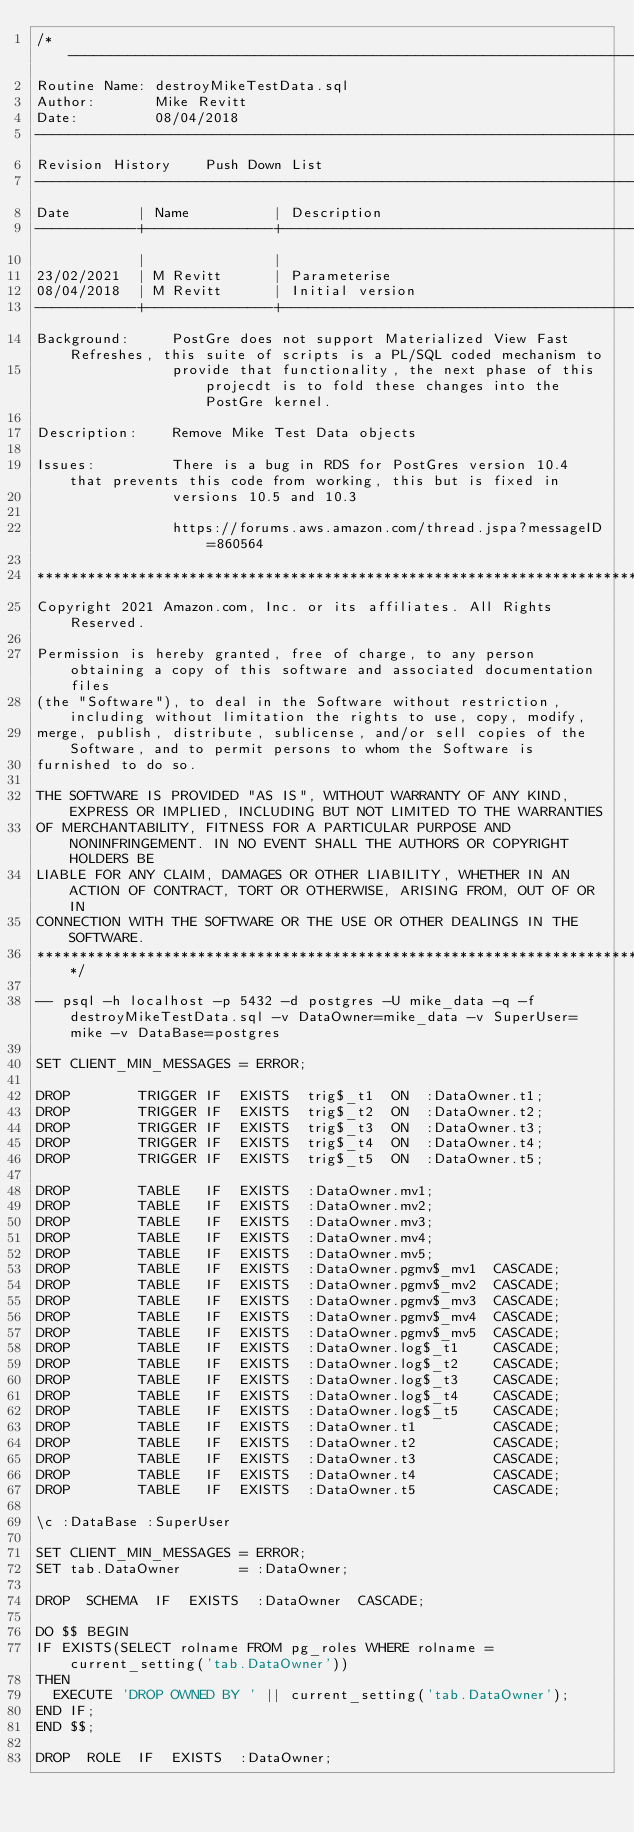Convert code to text. <code><loc_0><loc_0><loc_500><loc_500><_SQL_>/* ---------------------------------------------------------------------------------------------------------------------------------
Routine Name: destroyMikeTestData.sql
Author:       Mike Revitt
Date:         08/04/2018
------------------------------------------------------------------------------------------------------------------------------------
Revision History    Push Down List
------------------------------------------------------------------------------------------------------------------------------------
Date        | Name          | Description
------------+---------------+-------------------------------------------------------------------------------------------------------
            |               |
23/02/2021  | M Revitt      | Parameterise
08/04/2018  | M Revitt      | Initial version
------------+---------------+-------------------------------------------------------------------------------------------------------
Background:     PostGre does not support Materialized View Fast Refreshes, this suite of scripts is a PL/SQL coded mechanism to
                provide that functionality, the next phase of this projecdt is to fold these changes into the PostGre kernel.

Description:    Remove Mike Test Data objects

Issues:         There is a bug in RDS for PostGres version 10.4 that prevents this code from working, this but is fixed in
                versions 10.5 and 10.3

                https://forums.aws.amazon.com/thread.jspa?messageID=860564

************************************************************************************************************************************
Copyright 2021 Amazon.com, Inc. or its affiliates. All Rights Reserved.

Permission is hereby granted, free of charge, to any person obtaining a copy of this software and associated documentation files
(the "Software"), to deal in the Software without restriction, including without limitation the rights to use, copy, modify,
merge, publish, distribute, sublicense, and/or sell copies of the Software, and to permit persons to whom the Software is
furnished to do so.

THE SOFTWARE IS PROVIDED "AS IS", WITHOUT WARRANTY OF ANY KIND, EXPRESS OR IMPLIED, INCLUDING BUT NOT LIMITED TO THE WARRANTIES
OF MERCHANTABILITY, FITNESS FOR A PARTICULAR PURPOSE AND NONINFRINGEMENT. IN NO EVENT SHALL THE AUTHORS OR COPYRIGHT HOLDERS BE
LIABLE FOR ANY CLAIM, DAMAGES OR OTHER LIABILITY, WHETHER IN AN ACTION OF CONTRACT, TORT OR OTHERWISE, ARISING FROM, OUT OF OR IN
CONNECTION WITH THE SOFTWARE OR THE USE OR OTHER DEALINGS IN THE SOFTWARE.
***********************************************************************************************************************************/

-- psql -h localhost -p 5432 -d postgres -U mike_data -q -f destroyMikeTestData.sql -v DataOwner=mike_data -v SuperUser=mike -v DataBase=postgres

SET CLIENT_MIN_MESSAGES = ERROR;

DROP        TRIGGER IF  EXISTS  trig$_t1  ON  :DataOwner.t1;
DROP        TRIGGER IF  EXISTS  trig$_t2  ON  :DataOwner.t2;
DROP        TRIGGER IF  EXISTS  trig$_t3  ON  :DataOwner.t3;
DROP        TRIGGER IF  EXISTS  trig$_t4  ON  :DataOwner.t4;
DROP        TRIGGER IF  EXISTS  trig$_t5  ON  :DataOwner.t5;

DROP        TABLE   IF  EXISTS  :DataOwner.mv1;
DROP        TABLE   IF  EXISTS  :DataOwner.mv2;
DROP        TABLE   IF  EXISTS  :DataOwner.mv3;
DROP        TABLE   IF  EXISTS  :DataOwner.mv4;
DROP        TABLE   IF  EXISTS  :DataOwner.mv5;
DROP        TABLE   IF  EXISTS  :DataOwner.pgmv$_mv1  CASCADE;
DROP        TABLE   IF  EXISTS  :DataOwner.pgmv$_mv2  CASCADE;
DROP        TABLE   IF  EXISTS  :DataOwner.pgmv$_mv3  CASCADE;
DROP        TABLE   IF  EXISTS  :DataOwner.pgmv$_mv4  CASCADE;
DROP        TABLE   IF  EXISTS  :DataOwner.pgmv$_mv5  CASCADE;
DROP        TABLE   IF  EXISTS  :DataOwner.log$_t1    CASCADE;
DROP        TABLE   IF  EXISTS  :DataOwner.log$_t2    CASCADE;
DROP        TABLE   IF  EXISTS  :DataOwner.log$_t3    CASCADE;
DROP        TABLE   IF  EXISTS  :DataOwner.log$_t4    CASCADE;
DROP        TABLE   IF  EXISTS  :DataOwner.log$_t5    CASCADE;
DROP        TABLE   IF  EXISTS  :DataOwner.t1         CASCADE;
DROP        TABLE   IF  EXISTS  :DataOwner.t2         CASCADE;
DROP        TABLE   IF  EXISTS  :DataOwner.t3         CASCADE;
DROP        TABLE   IF  EXISTS  :DataOwner.t4         CASCADE;
DROP        TABLE   IF  EXISTS  :DataOwner.t5         CASCADE;

\c :DataBase :SuperUser

SET CLIENT_MIN_MESSAGES = ERROR;
SET tab.DataOwner       = :DataOwner;

DROP  SCHEMA  IF  EXISTS  :DataOwner  CASCADE;

DO $$ BEGIN
IF EXISTS(SELECT rolname FROM pg_roles WHERE rolname = current_setting('tab.DataOwner'))
THEN
  EXECUTE 'DROP OWNED BY ' || current_setting('tab.DataOwner');
END IF;
END $$;

DROP  ROLE  IF  EXISTS  :DataOwner;
</code> 